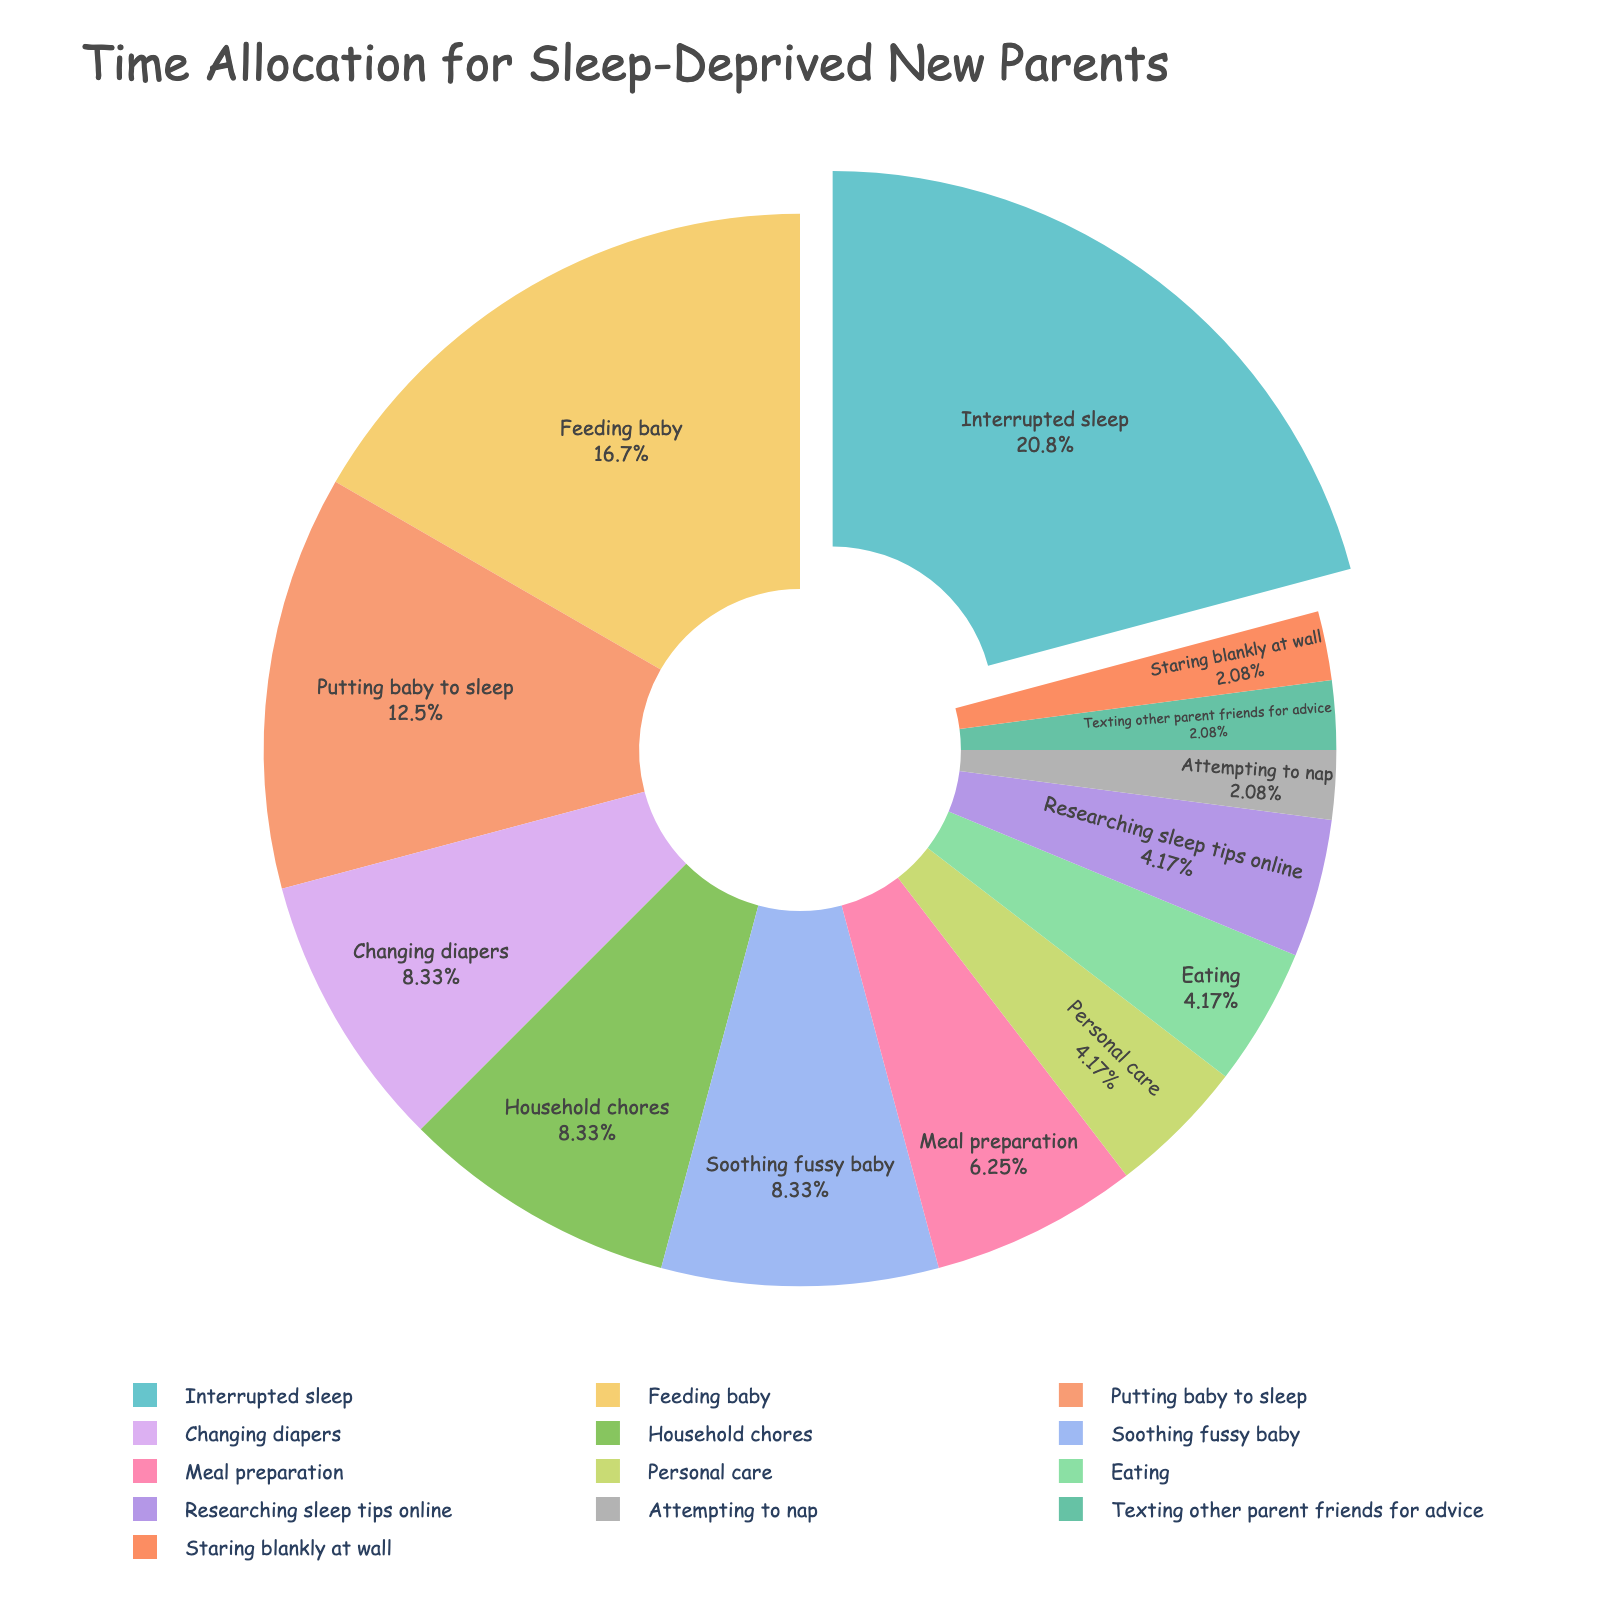How many hours are dedicated to baby-related tasks (Feeding baby, Changing diapers, Putting baby to sleep, and Soothing fussy baby)? Sum the hours for Feeding baby (4), Changing diapers (2), Putting baby to sleep (3), and Soothing fussy baby (2). 4 + 2 + 3 + 2 = 11 hours
Answer: 11 hours Which activity takes up the most time? By visually identifying the largest slice in the pie chart, which corresponds to Interrupted sleep, taking 5 hours
Answer: Interrupted sleep How do the hours allocated to Attempting to nap compare to Personal care? By comparing their slice sizes, Attempting to nap is 0.5 hours, and Personal care is 1 hour. 1 > 0.5
Answer: Personal care What percentage of the day is spent on Meal preparation? The figure shows 1.5 hours on meal prep. The total hours in the chart sum to 24. The percentage is (1.5 / 24) * 100 = 6.25%
Answer: 6.25% Are there any activities equally divided in time allocation? By examining the pie chart, both Texting other parent friends for advice and Staring blankly at wall are allocated 0.5 hours each
Answer: Yes Which activity's slice is pulled out from the pie chart and why? The slice for Interrupted sleep is pulled out. Typically, the slice with the highest value (Interrupted sleep, 5 hours) is highlighted this way
Answer: Interrupted sleep How many hours in total are spent on self-care activities like Personal care, Attempting to nap, and Eating? Add the hours: Personal care (1) + Attempting to nap (0.5) + Eating (1). 1 + 0.5 + 1 = 2.5 hours
Answer: 2.5 hours Among Researching sleep tips online and Texting other parent friends for advice, which one takes more time? According to the pie chart, Researching sleep tips online takes 1 hour while Texting other parent friends takes 0.5 hours. 1 > 0.5
Answer: Researching sleep tips online If you were to redistribute Interrupted sleep hours evenly across Feeding baby and Putting baby to sleep, how many hours would each have? Split 5 hours of Interrupted sleep into two: 5 / 2 = 2.5. Add 2.5 hours to each existing time, Feeding baby: 4 + 2.5 = 6.5 hours, Putting baby to sleep: 3 + 2.5 = 5.5 hours
Answer: Feeding baby: 6.5 hours, Putting baby to sleep: 5.5 hours 